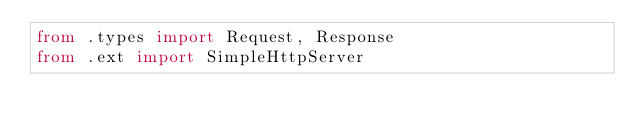<code> <loc_0><loc_0><loc_500><loc_500><_Python_>from .types import Request, Response
from .ext import SimpleHttpServer
</code> 